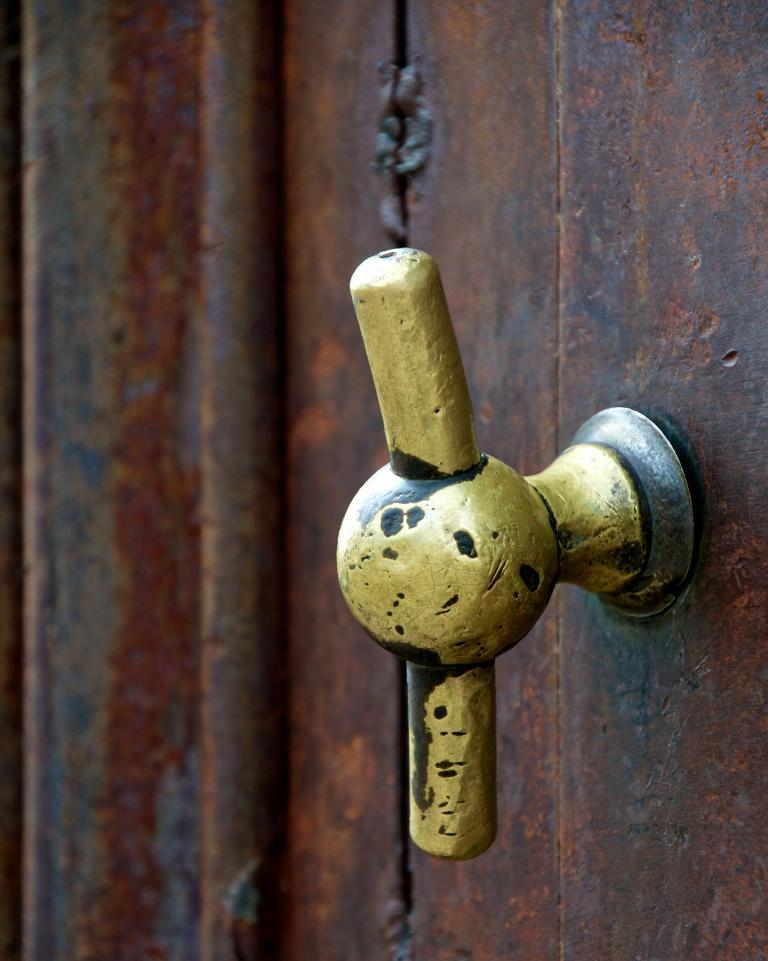What type of object is made of metal in the image? There is a metal object in the image, but the specific type is not mentioned. What can be used to open a door in the image? There is a door handle in the image, which can be used to open a door. What type of structure is present in the image? There is a pipe in the image, which is a type of structure. How many jars are visible in the image? There are no jars present in the image. What type of animal can be seen interacting with the pipe in the image? There are no animals, including pigs, present in the image. 